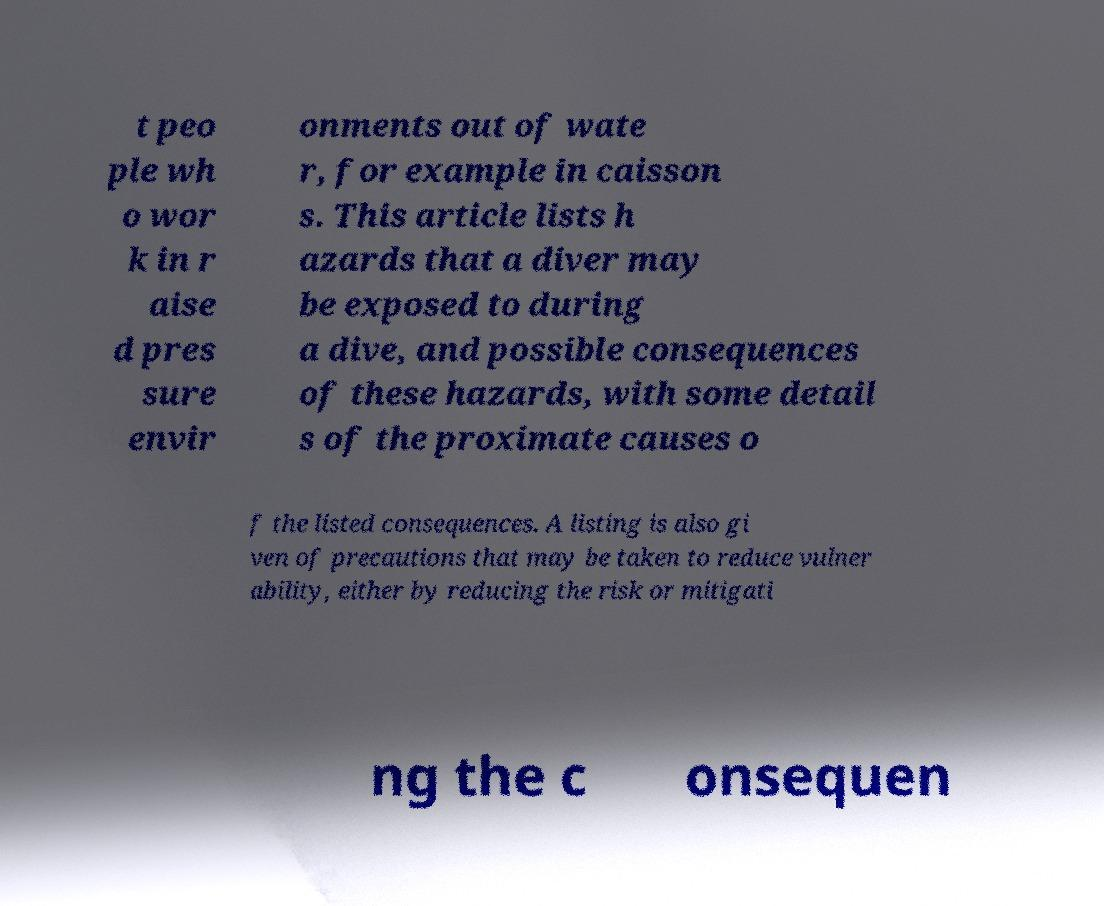Can you read and provide the text displayed in the image?This photo seems to have some interesting text. Can you extract and type it out for me? t peo ple wh o wor k in r aise d pres sure envir onments out of wate r, for example in caisson s. This article lists h azards that a diver may be exposed to during a dive, and possible consequences of these hazards, with some detail s of the proximate causes o f the listed consequences. A listing is also gi ven of precautions that may be taken to reduce vulner ability, either by reducing the risk or mitigati ng the c onsequen 